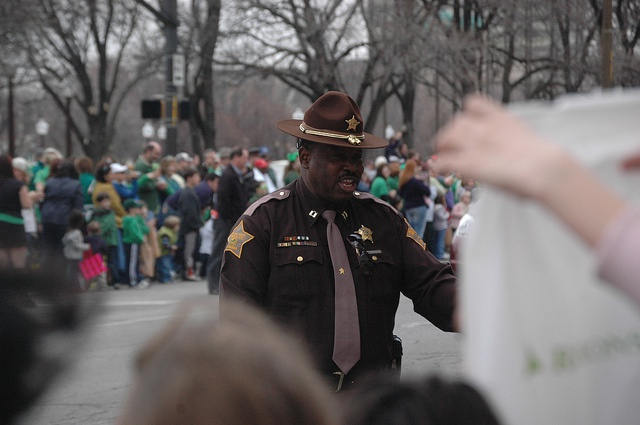Describe the objects in this image and their specific colors. I can see people in black, gray, and darkgray tones, people in black, gray, and darkgray tones, people in black, darkgray, gray, and lightgray tones, people in black and gray tones, and tie in black and gray tones in this image. 